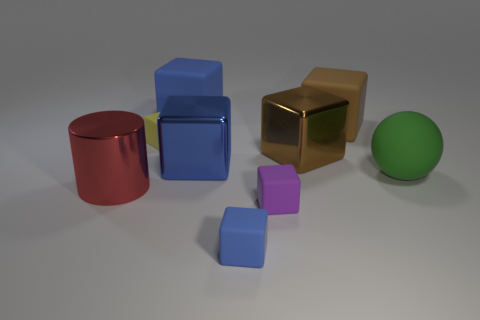Are there any other things that have the same shape as the big green thing?
Provide a succinct answer. No. There is a blue matte object that is in front of the green rubber sphere; what number of large cubes are behind it?
Your response must be concise. 4. What is the size of the blue cube that is behind the big brown thing that is behind the small rubber object that is behind the metallic cylinder?
Provide a short and direct response. Large. The yellow object that is the same shape as the purple matte object is what size?
Offer a very short reply. Small. How many things are either big blue blocks that are behind the big brown metallic thing or rubber cubes that are on the right side of the yellow matte cube?
Give a very brief answer. 4. The small thing that is left of the blue cube in front of the green ball is what shape?
Keep it short and to the point. Cube. How many things are green objects or large rubber things?
Give a very brief answer. 3. Is there a blue shiny thing of the same size as the blue metal cube?
Offer a terse response. No. The large brown shiny thing has what shape?
Your response must be concise. Cube. Is the number of tiny things that are behind the large cylinder greater than the number of big brown things on the left side of the tiny purple thing?
Ensure brevity in your answer.  Yes. 